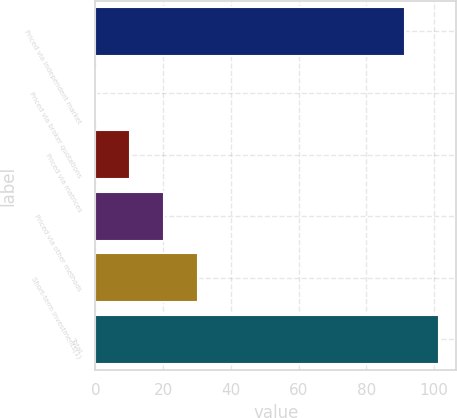Convert chart to OTSL. <chart><loc_0><loc_0><loc_500><loc_500><bar_chart><fcel>Priced via independent market<fcel>Priced via broker quotations<fcel>Priced via matrices<fcel>Priced via other methods<fcel>Short-term investments(1)<fcel>Total<nl><fcel>91.5<fcel>0.3<fcel>10.27<fcel>20.24<fcel>30.21<fcel>101.47<nl></chart> 